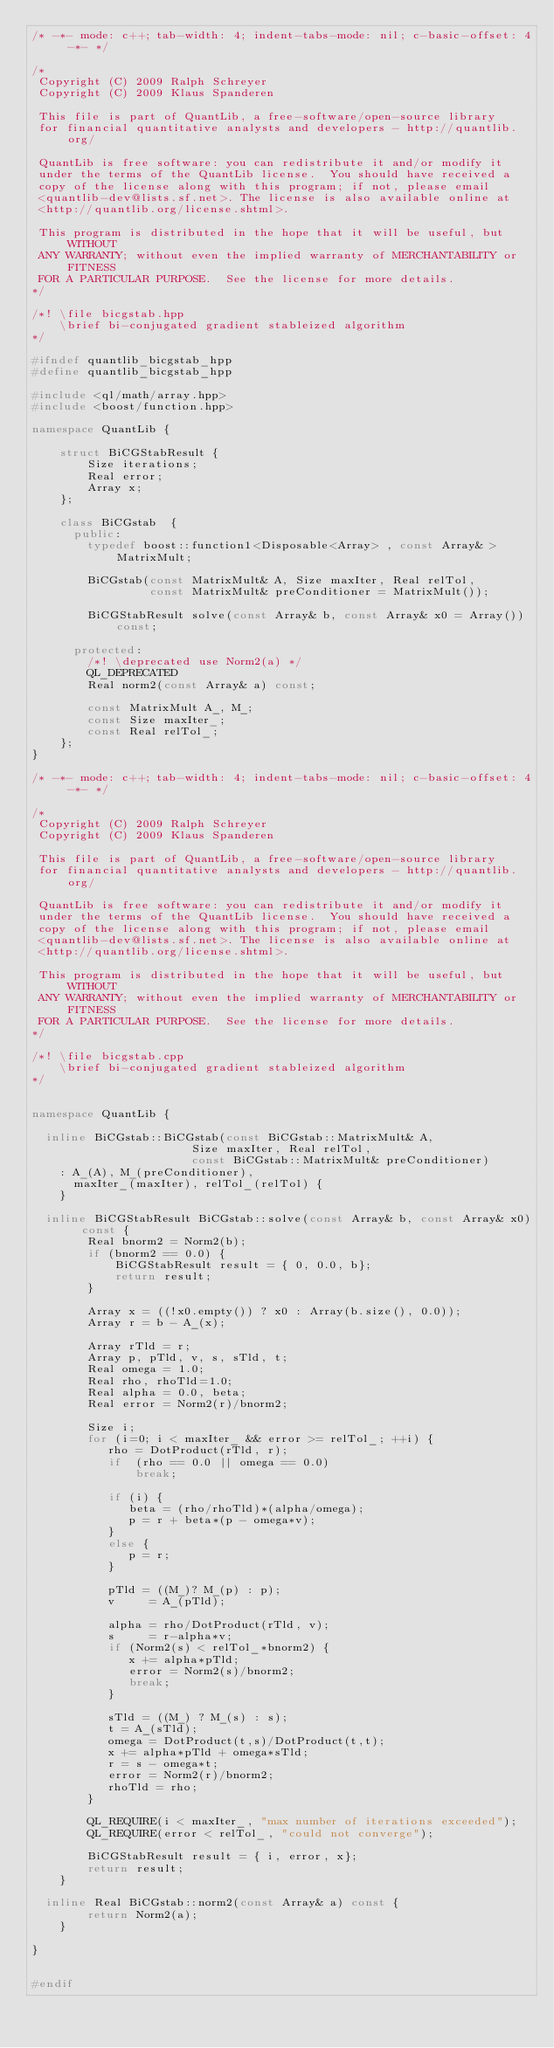Convert code to text. <code><loc_0><loc_0><loc_500><loc_500><_C++_>/* -*- mode: c++; tab-width: 4; indent-tabs-mode: nil; c-basic-offset: 4 -*- */

/*
 Copyright (C) 2009 Ralph Schreyer
 Copyright (C) 2009 Klaus Spanderen

 This file is part of QuantLib, a free-software/open-source library
 for financial quantitative analysts and developers - http://quantlib.org/

 QuantLib is free software: you can redistribute it and/or modify it
 under the terms of the QuantLib license.  You should have received a
 copy of the license along with this program; if not, please email
 <quantlib-dev@lists.sf.net>. The license is also available online at
 <http://quantlib.org/license.shtml>.

 This program is distributed in the hope that it will be useful, but WITHOUT
 ANY WARRANTY; without even the implied warranty of MERCHANTABILITY or FITNESS
 FOR A PARTICULAR PURPOSE.  See the license for more details.
*/

/*! \file bicgstab.hpp
    \brief bi-conjugated gradient stableized algorithm
*/

#ifndef quantlib_bicgstab_hpp
#define quantlib_bicgstab_hpp

#include <ql/math/array.hpp>
#include <boost/function.hpp>

namespace QuantLib {

    struct BiCGStabResult {
        Size iterations;
        Real error;
        Array x;
    };

    class BiCGstab  {
      public:
        typedef boost::function1<Disposable<Array> , const Array& > MatrixMult;
        
        BiCGstab(const MatrixMult& A, Size maxIter, Real relTol,
                 const MatrixMult& preConditioner = MatrixMult());
        
        BiCGStabResult solve(const Array& b, const Array& x0 = Array()) const;
        
      protected:
        /*! \deprecated use Norm2(a) */
        QL_DEPRECATED
        Real norm2(const Array& a) const;

        const MatrixMult A_, M_;
        const Size maxIter_;
        const Real relTol_;  
    };
}

/* -*- mode: c++; tab-width: 4; indent-tabs-mode: nil; c-basic-offset: 4 -*- */

/*
 Copyright (C) 2009 Ralph Schreyer
 Copyright (C) 2009 Klaus Spanderen

 This file is part of QuantLib, a free-software/open-source library
 for financial quantitative analysts and developers - http://quantlib.org/

 QuantLib is free software: you can redistribute it and/or modify it
 under the terms of the QuantLib license.  You should have received a
 copy of the license along with this program; if not, please email
 <quantlib-dev@lists.sf.net>. The license is also available online at
 <http://quantlib.org/license.shtml>.

 This program is distributed in the hope that it will be useful, but WITHOUT
 ANY WARRANTY; without even the implied warranty of MERCHANTABILITY or FITNESS
 FOR A PARTICULAR PURPOSE.  See the license for more details.
*/

/*! \file bicgstab.cpp
    \brief bi-conjugated gradient stableized algorithm
*/


namespace QuantLib {

  inline BiCGstab::BiCGstab(const BiCGstab::MatrixMult& A,
                       Size maxIter, Real relTol,
                       const BiCGstab::MatrixMult& preConditioner)
    : A_(A), M_(preConditioner),
      maxIter_(maxIter), relTol_(relTol) {
    }

  inline BiCGStabResult BiCGstab::solve(const Array& b, const Array& x0) const {
        Real bnorm2 = Norm2(b);
        if (bnorm2 == 0.0) {
            BiCGStabResult result = { 0, 0.0, b};
            return result;
        }

        Array x = ((!x0.empty()) ? x0 : Array(b.size(), 0.0));
        Array r = b - A_(x);

        Array rTld = r;
        Array p, pTld, v, s, sTld, t;
        Real omega = 1.0;
        Real rho, rhoTld=1.0;
        Real alpha = 0.0, beta;
        Real error = Norm2(r)/bnorm2;

        Size i;
        for (i=0; i < maxIter_ && error >= relTol_; ++i) {
           rho = DotProduct(rTld, r);
           if  (rho == 0.0 || omega == 0.0)
               break;

           if (i) {
              beta = (rho/rhoTld)*(alpha/omega);
              p = r + beta*(p - omega*v);
           }
           else {
              p = r;
           }

           pTld = ((M_)? M_(p) : p);
           v     = A_(pTld);

           alpha = rho/DotProduct(rTld, v);
           s     = r-alpha*v;
           if (Norm2(s) < relTol_*bnorm2) {
              x += alpha*pTld;
              error = Norm2(s)/bnorm2;
              break;
           }

           sTld = ((M_) ? M_(s) : s);
           t = A_(sTld);
           omega = DotProduct(t,s)/DotProduct(t,t);
           x += alpha*pTld + omega*sTld;
           r = s - omega*t;
           error = Norm2(r)/bnorm2;
           rhoTld = rho;
        }

        QL_REQUIRE(i < maxIter_, "max number of iterations exceeded");
        QL_REQUIRE(error < relTol_, "could not converge");

        BiCGStabResult result = { i, error, x};
        return result;
    }

  inline Real BiCGstab::norm2(const Array& a) const {
        return Norm2(a);
    }

}


#endif
</code> 